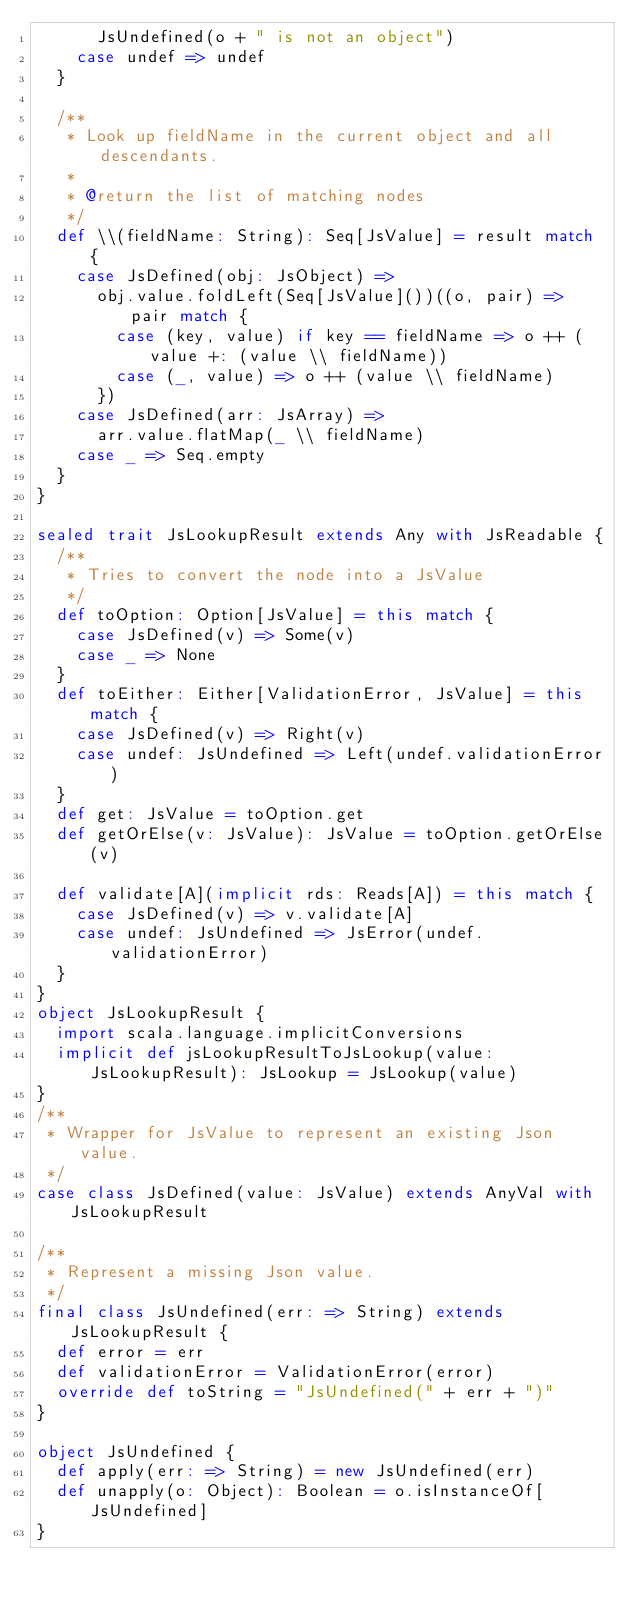Convert code to text. <code><loc_0><loc_0><loc_500><loc_500><_Scala_>      JsUndefined(o + " is not an object")
    case undef => undef
  }

  /**
   * Look up fieldName in the current object and all descendants.
   *
   * @return the list of matching nodes
   */
  def \\(fieldName: String): Seq[JsValue] = result match {
    case JsDefined(obj: JsObject) =>
      obj.value.foldLeft(Seq[JsValue]())((o, pair) => pair match {
        case (key, value) if key == fieldName => o ++ (value +: (value \\ fieldName))
        case (_, value) => o ++ (value \\ fieldName)
      })
    case JsDefined(arr: JsArray) =>
      arr.value.flatMap(_ \\ fieldName)
    case _ => Seq.empty
  }
}

sealed trait JsLookupResult extends Any with JsReadable {
  /**
   * Tries to convert the node into a JsValue
   */
  def toOption: Option[JsValue] = this match {
    case JsDefined(v) => Some(v)
    case _ => None
  }
  def toEither: Either[ValidationError, JsValue] = this match {
    case JsDefined(v) => Right(v)
    case undef: JsUndefined => Left(undef.validationError)
  }
  def get: JsValue = toOption.get
  def getOrElse(v: JsValue): JsValue = toOption.getOrElse(v)

  def validate[A](implicit rds: Reads[A]) = this match {
    case JsDefined(v) => v.validate[A]
    case undef: JsUndefined => JsError(undef.validationError)
  }
}
object JsLookupResult {
  import scala.language.implicitConversions
  implicit def jsLookupResultToJsLookup(value: JsLookupResult): JsLookup = JsLookup(value)
}
/**
 * Wrapper for JsValue to represent an existing Json value.
 */
case class JsDefined(value: JsValue) extends AnyVal with JsLookupResult

/**
 * Represent a missing Json value.
 */
final class JsUndefined(err: => String) extends JsLookupResult {
  def error = err
  def validationError = ValidationError(error)
  override def toString = "JsUndefined(" + err + ")"
}

object JsUndefined {
  def apply(err: => String) = new JsUndefined(err)
  def unapply(o: Object): Boolean = o.isInstanceOf[JsUndefined]
}
</code> 